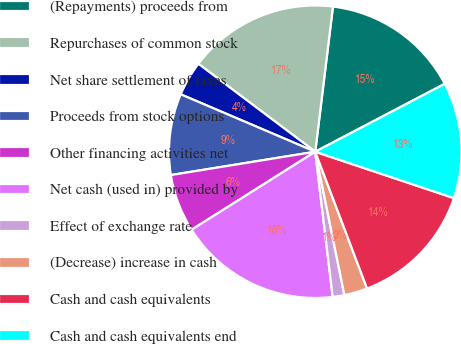<chart> <loc_0><loc_0><loc_500><loc_500><pie_chart><fcel>(Repayments) proceeds from<fcel>Repurchases of common stock<fcel>Net share settlement of taxes<fcel>Proceeds from stock options<fcel>Other financing activities net<fcel>Net cash (used in) provided by<fcel>Effect of exchange rate<fcel>(Decrease) increase in cash<fcel>Cash and cash equivalents<fcel>Cash and cash equivalents end<nl><fcel>15.38%<fcel>16.66%<fcel>3.85%<fcel>8.97%<fcel>6.41%<fcel>17.94%<fcel>1.29%<fcel>2.57%<fcel>14.1%<fcel>12.82%<nl></chart> 